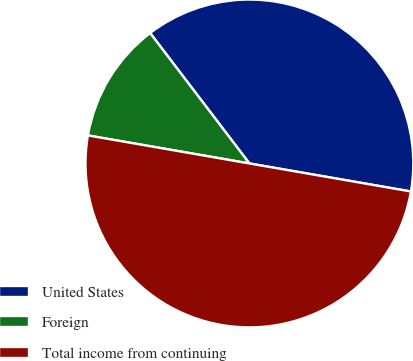<chart> <loc_0><loc_0><loc_500><loc_500><pie_chart><fcel>United States<fcel>Foreign<fcel>Total income from continuing<nl><fcel>38.09%<fcel>11.91%<fcel>50.0%<nl></chart> 